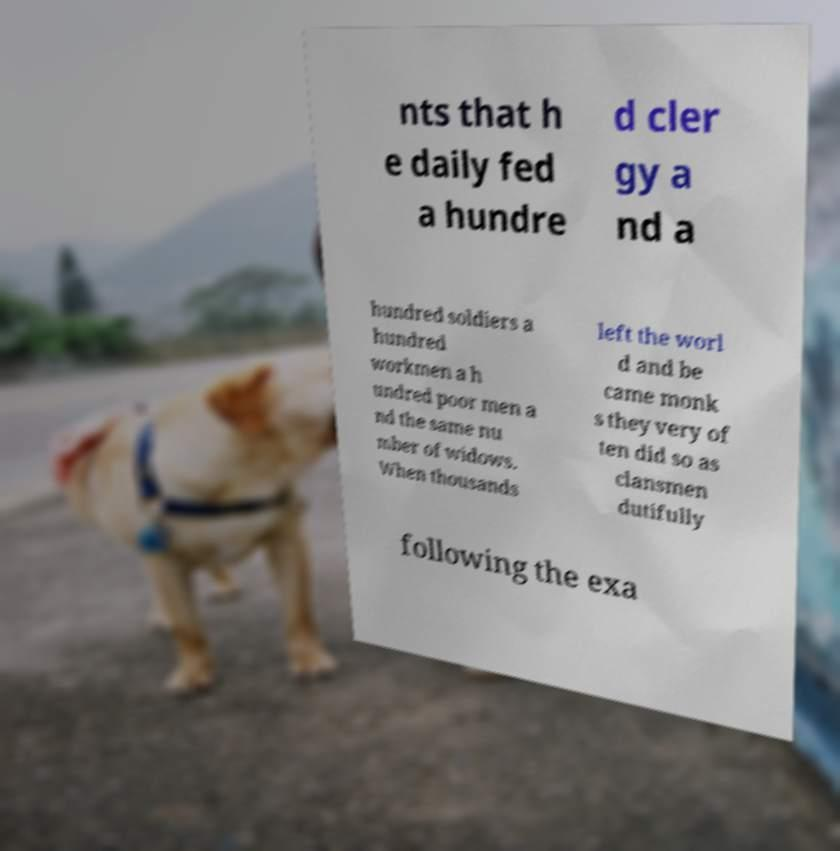Can you read and provide the text displayed in the image?This photo seems to have some interesting text. Can you extract and type it out for me? nts that h e daily fed a hundre d cler gy a nd a hundred soldiers a hundred workmen a h undred poor men a nd the same nu mber of widows. When thousands left the worl d and be came monk s they very of ten did so as clansmen dutifully following the exa 